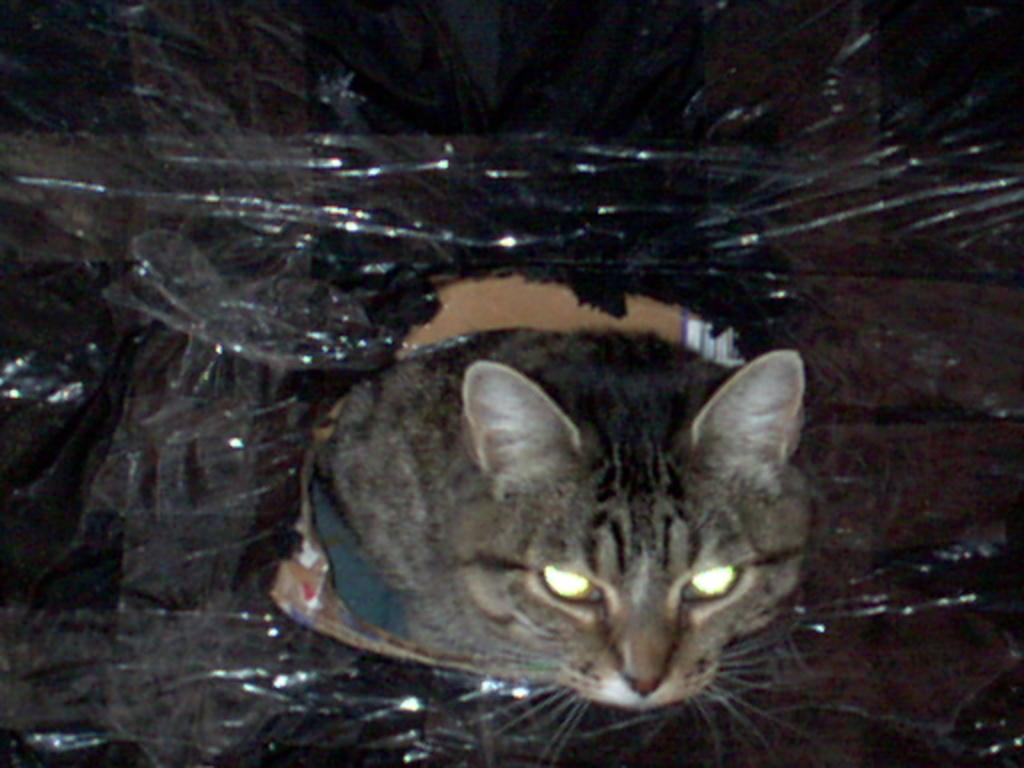What type of animal is in the image? There is a cat in the image. What color is the cat in the image? The cat in the image is black. What type of wool is being used for the cat's treatment in the image? There is no wool or treatment present in the image; it features a cat. What type of cloud can be seen in the image? There is no cloud present in the image; it features a cat. 